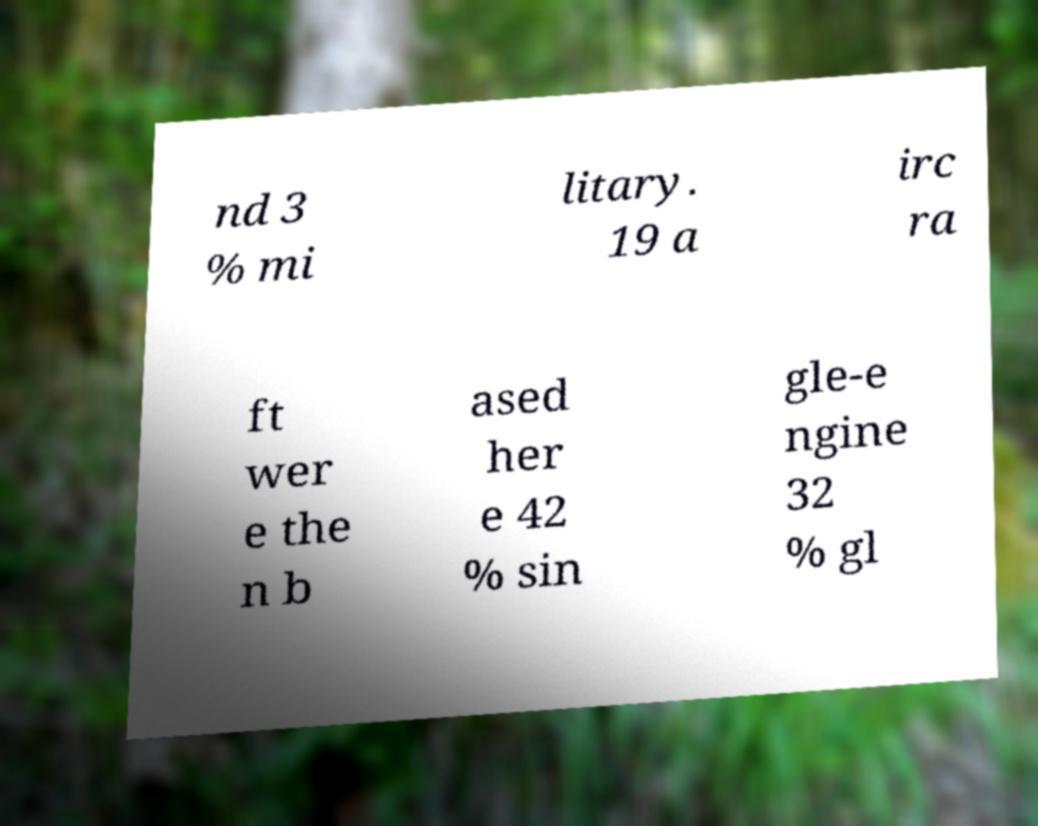Could you extract and type out the text from this image? nd 3 % mi litary. 19 a irc ra ft wer e the n b ased her e 42 % sin gle-e ngine 32 % gl 